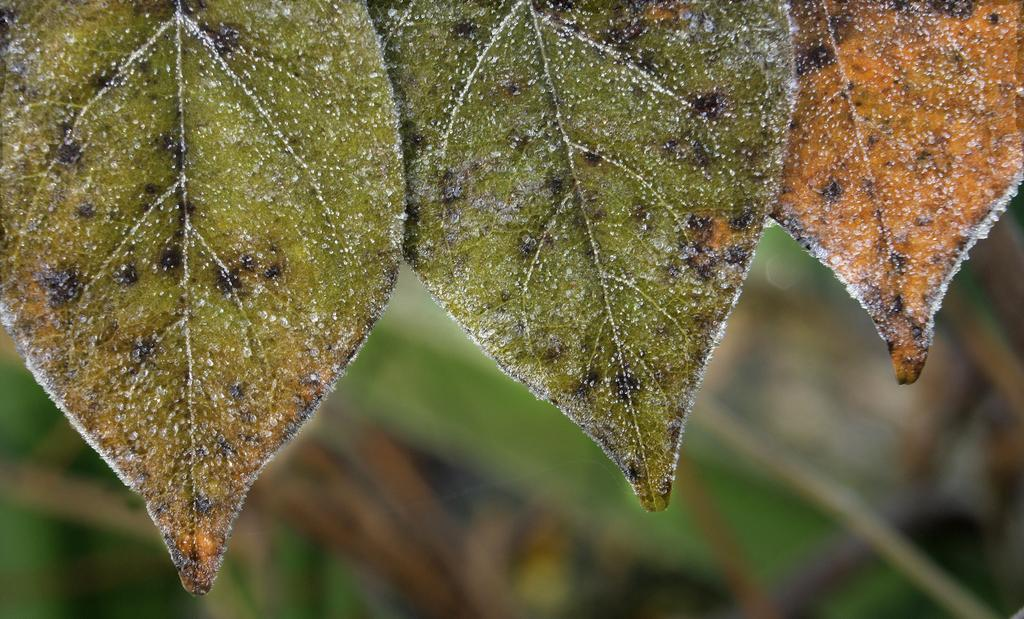How many leaves are present in the image? There are three leaves in the image. What colors can be seen on the leaves? The leaves have green, black, and orange colors. Can you describe the background of the image? The background of the image is blurry. What else can be seen in the background? There are trees visible in the background. What type of skin can be seen on the leaves in the image? Leaves do not have skin; they have a surface made up of cells and other structures. 